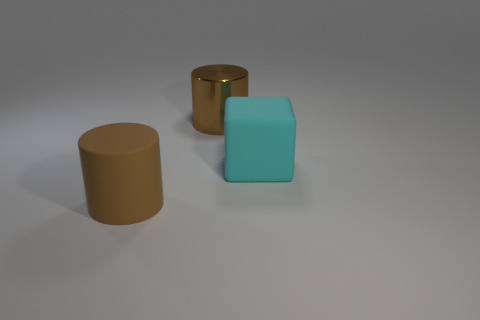Add 3 large red cubes. How many objects exist? 6 Subtract all cylinders. How many objects are left? 1 Add 3 cyan rubber objects. How many cyan rubber objects are left? 4 Add 3 large gray matte cubes. How many large gray matte cubes exist? 3 Subtract 1 cyan cubes. How many objects are left? 2 Subtract all tiny gray rubber blocks. Subtract all cyan things. How many objects are left? 2 